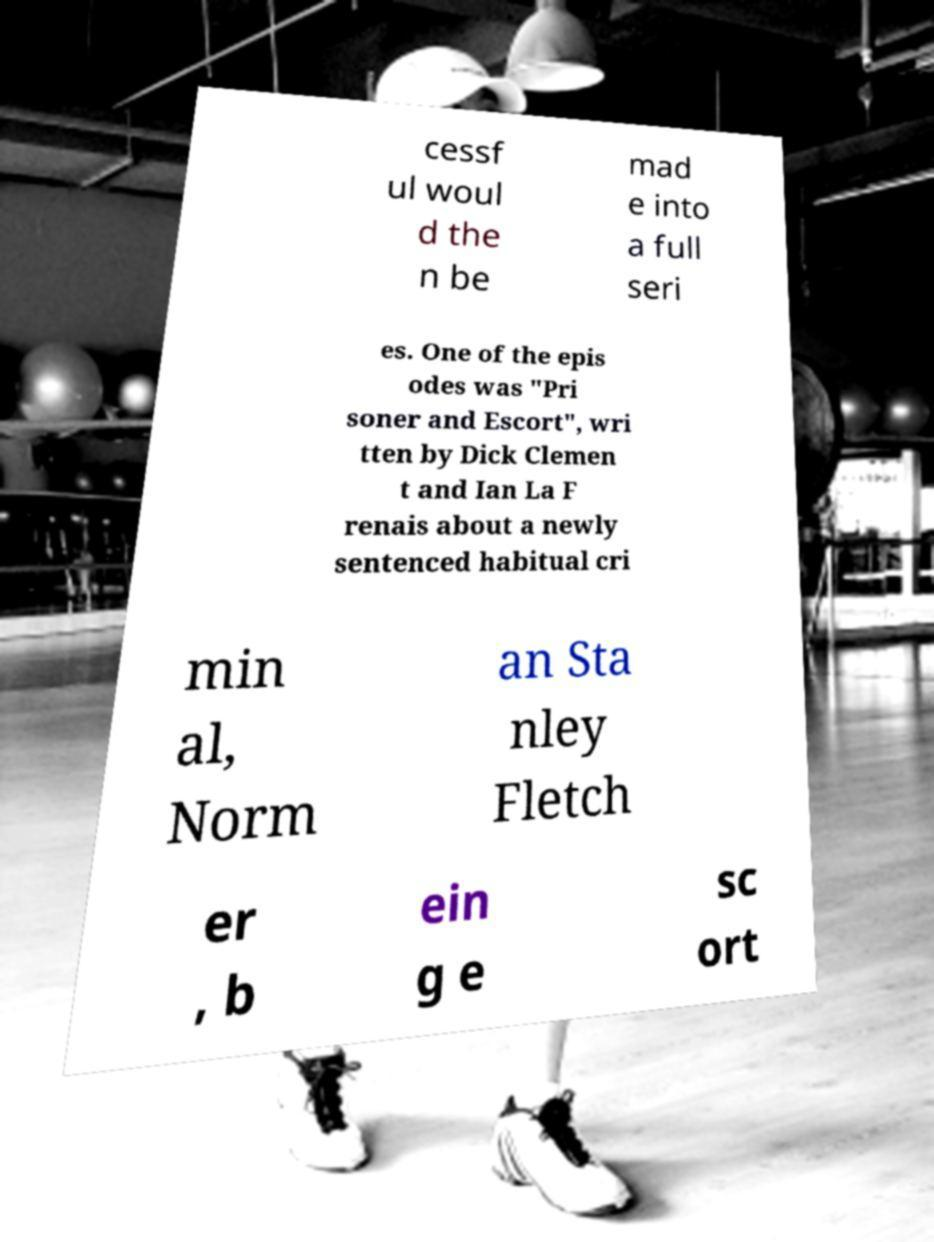There's text embedded in this image that I need extracted. Can you transcribe it verbatim? cessf ul woul d the n be mad e into a full seri es. One of the epis odes was "Pri soner and Escort", wri tten by Dick Clemen t and Ian La F renais about a newly sentenced habitual cri min al, Norm an Sta nley Fletch er , b ein g e sc ort 